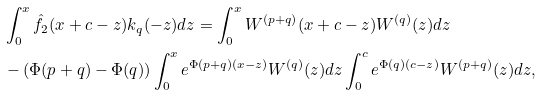<formula> <loc_0><loc_0><loc_500><loc_500>& \int _ { 0 } ^ { x } \hat { f } _ { 2 } ( x + c - z ) k _ { q } ( - z ) d z = \int _ { 0 } ^ { x } W ^ { ( p + q ) } ( x + c - z ) W ^ { ( q ) } ( z ) d z \\ & - ( \Phi ( p + q ) - \Phi ( q ) ) \int _ { 0 } ^ { x } e ^ { \Phi ( p + q ) ( x - z ) } W ^ { ( q ) } ( z ) d z \int _ { 0 } ^ { c } e ^ { \Phi ( q ) ( c - z ) } W ^ { ( p + q ) } ( z ) d z ,</formula> 